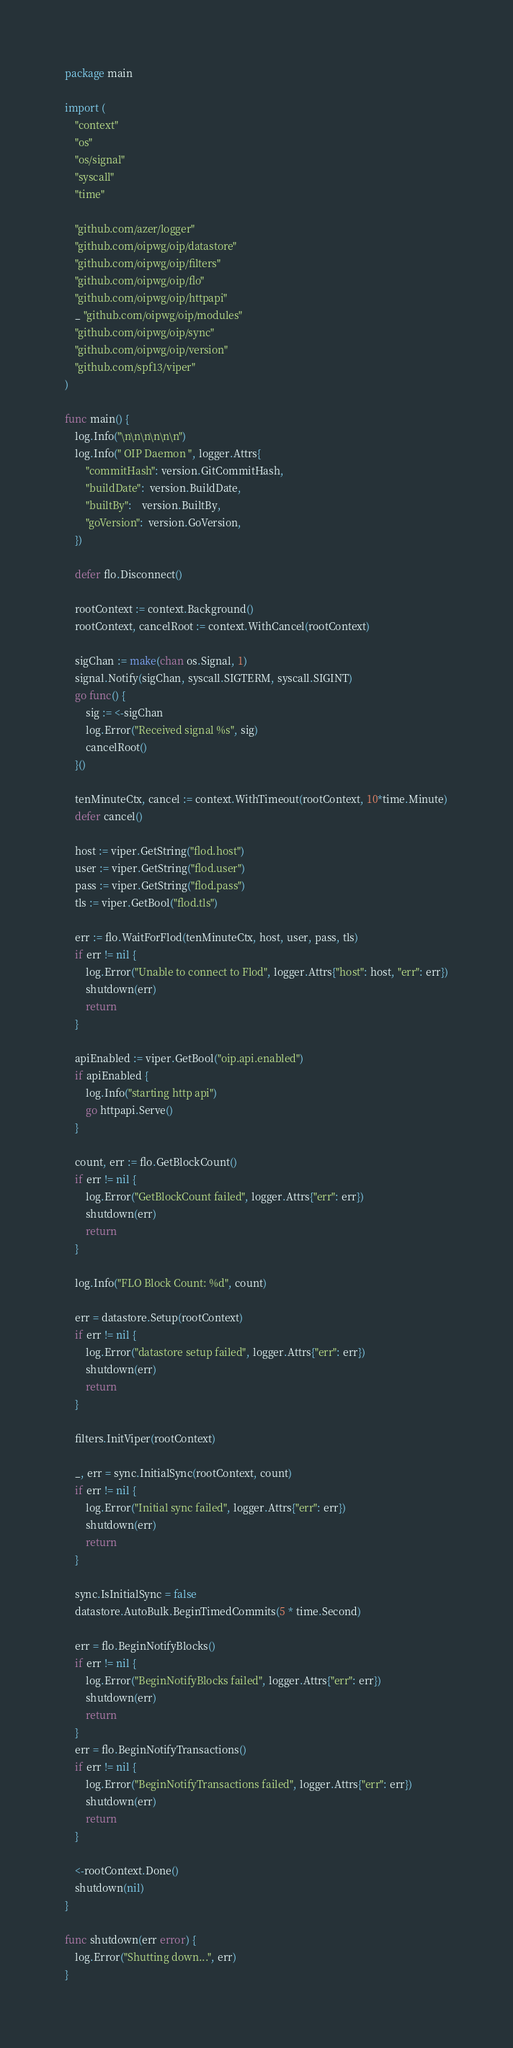Convert code to text. <code><loc_0><loc_0><loc_500><loc_500><_Go_>package main

import (
	"context"
	"os"
	"os/signal"
	"syscall"
	"time"

	"github.com/azer/logger"
	"github.com/oipwg/oip/datastore"
	"github.com/oipwg/oip/filters"
	"github.com/oipwg/oip/flo"
	"github.com/oipwg/oip/httpapi"
	_ "github.com/oipwg/oip/modules"
	"github.com/oipwg/oip/sync"
	"github.com/oipwg/oip/version"
	"github.com/spf13/viper"
)

func main() {
	log.Info("\n\n\n\n\n\n")
	log.Info(" OIP Daemon ", logger.Attrs{
		"commitHash": version.GitCommitHash,
		"buildDate":  version.BuildDate,
		"builtBy":    version.BuiltBy,
		"goVersion":  version.GoVersion,
	})

	defer flo.Disconnect()

	rootContext := context.Background()
	rootContext, cancelRoot := context.WithCancel(rootContext)

	sigChan := make(chan os.Signal, 1)
	signal.Notify(sigChan, syscall.SIGTERM, syscall.SIGINT)
	go func() {
		sig := <-sigChan
		log.Error("Received signal %s", sig)
		cancelRoot()
	}()

	tenMinuteCtx, cancel := context.WithTimeout(rootContext, 10*time.Minute)
	defer cancel()

	host := viper.GetString("flod.host")
	user := viper.GetString("flod.user")
	pass := viper.GetString("flod.pass")
	tls := viper.GetBool("flod.tls")

	err := flo.WaitForFlod(tenMinuteCtx, host, user, pass, tls)
	if err != nil {
		log.Error("Unable to connect to Flod", logger.Attrs{"host": host, "err": err})
		shutdown(err)
		return
	}

	apiEnabled := viper.GetBool("oip.api.enabled")
	if apiEnabled {
		log.Info("starting http api")
		go httpapi.Serve()
	}

	count, err := flo.GetBlockCount()
	if err != nil {
		log.Error("GetBlockCount failed", logger.Attrs{"err": err})
		shutdown(err)
		return
	}

	log.Info("FLO Block Count: %d", count)

	err = datastore.Setup(rootContext)
	if err != nil {
		log.Error("datastore setup failed", logger.Attrs{"err": err})
		shutdown(err)
		return
	}

	filters.InitViper(rootContext)

	_, err = sync.InitialSync(rootContext, count)
	if err != nil {
		log.Error("Initial sync failed", logger.Attrs{"err": err})
		shutdown(err)
		return
	}

	sync.IsInitialSync = false
	datastore.AutoBulk.BeginTimedCommits(5 * time.Second)

	err = flo.BeginNotifyBlocks()
	if err != nil {
		log.Error("BeginNotifyBlocks failed", logger.Attrs{"err": err})
		shutdown(err)
		return
	}
	err = flo.BeginNotifyTransactions()
	if err != nil {
		log.Error("BeginNotifyTransactions failed", logger.Attrs{"err": err})
		shutdown(err)
		return
	}

	<-rootContext.Done()
	shutdown(nil)
}

func shutdown(err error) {
	log.Error("Shutting down...", err)
}
</code> 